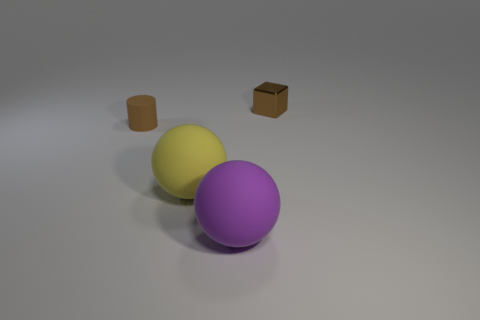There is a small metal thing behind the yellow matte ball; does it have the same color as the small matte thing?
Offer a terse response. Yes. There is a metal thing; is it the same color as the small object that is to the left of the block?
Your response must be concise. Yes. What number of other objects are there of the same material as the small brown cylinder?
Keep it short and to the point. 2. The purple object that is the same material as the brown cylinder is what shape?
Keep it short and to the point. Sphere. Is there any other thing that is the same color as the cylinder?
Provide a short and direct response. Yes. What size is the object that is the same color as the cylinder?
Your response must be concise. Small. Is the number of things behind the yellow ball greater than the number of brown shiny blocks?
Ensure brevity in your answer.  Yes. Is the shape of the yellow rubber object the same as the rubber object that is on the right side of the large yellow matte thing?
Keep it short and to the point. Yes. How many brown things are the same size as the cylinder?
Offer a very short reply. 1. There is a big purple sphere that is to the right of the small object that is in front of the metallic object; how many spheres are to the left of it?
Offer a terse response. 1. 